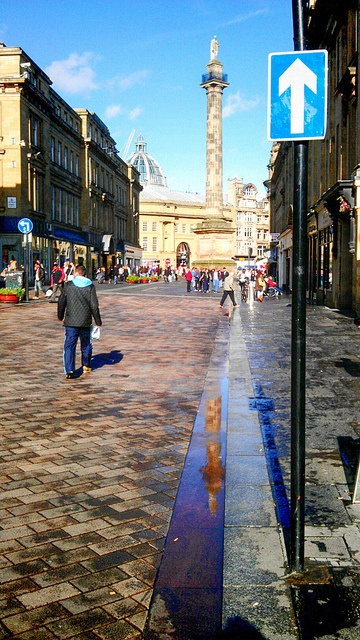Describe the objects in this image and their specific colors. I can see people in lightblue, darkgray, black, gray, and white tones, people in lightblue, black, gray, navy, and darkblue tones, people in lightblue, black, gray, and maroon tones, people in lightblue, black, gray, white, and darkgray tones, and people in lightblue, beige, black, tan, and gray tones in this image. 